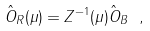Convert formula to latex. <formula><loc_0><loc_0><loc_500><loc_500>\hat { O } _ { R } ( \mu ) = Z ^ { - 1 } ( \mu ) \hat { O } _ { B } \ ,</formula> 